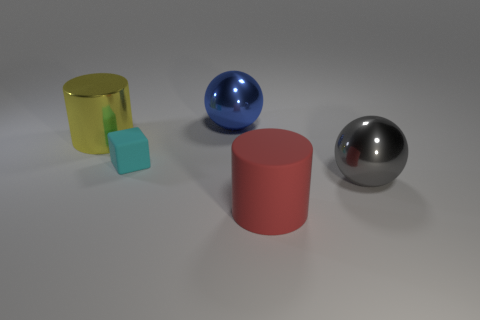Add 1 large cyan rubber cylinders. How many objects exist? 6 Subtract 0 purple cylinders. How many objects are left? 5 Subtract all blocks. How many objects are left? 4 Subtract 1 cubes. How many cubes are left? 0 Subtract all gray cylinders. Subtract all cyan spheres. How many cylinders are left? 2 Subtract all green cylinders. How many blue blocks are left? 0 Subtract all tiny cyan things. Subtract all tiny matte things. How many objects are left? 3 Add 1 big cylinders. How many big cylinders are left? 3 Add 2 large brown blocks. How many large brown blocks exist? 2 Subtract all blue balls. How many balls are left? 1 